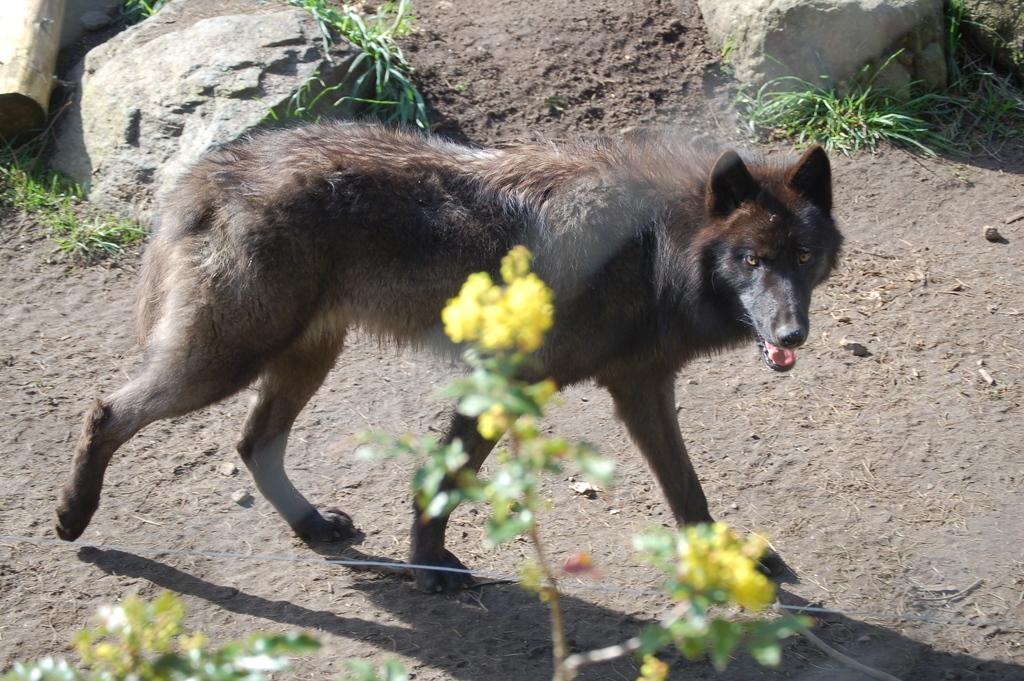What type of animal is in the image? The type of animal cannot be determined from the provided facts. What can be seen in the background of the image? In the background of the image, there are rocks, grass, and other objects. What is the plant at the bottom of the image? The plant at the bottom of the image has yellow flowers. Can you see the ocean in the image? No, the ocean is not present in the image. What type of fork is being used by the animal in the image? There is no fork present in the image, and the animal's actions cannot be determined from the provided facts. 